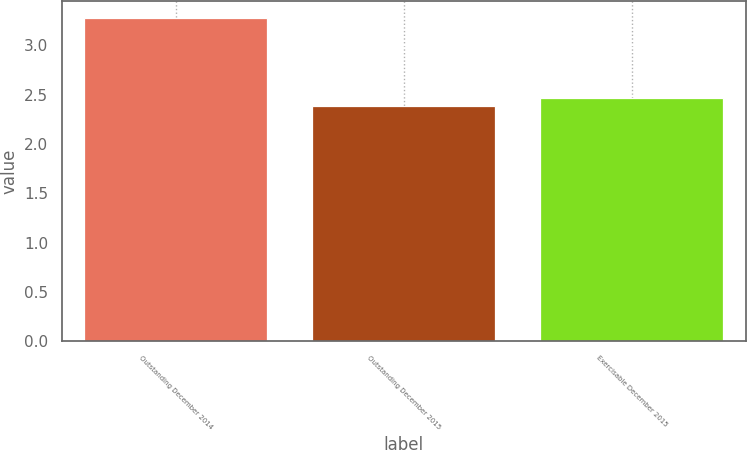<chart> <loc_0><loc_0><loc_500><loc_500><bar_chart><fcel>Outstanding December 2014<fcel>Outstanding December 2015<fcel>Exercisable December 2015<nl><fcel>3.28<fcel>2.38<fcel>2.47<nl></chart> 